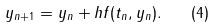<formula> <loc_0><loc_0><loc_500><loc_500>y _ { n + 1 } = y _ { n } + h f ( t _ { n } , y _ { n } ) . \quad ( 4 )</formula> 